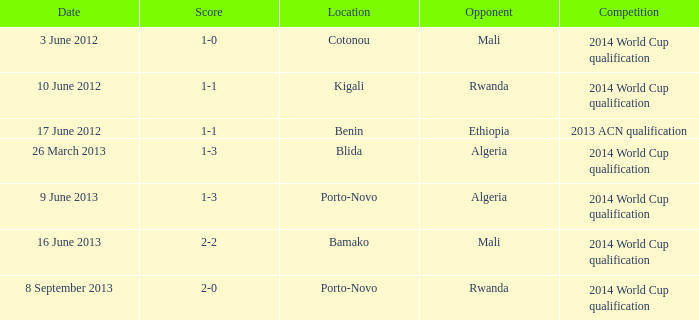What competition is located in bamako? 2014 World Cup qualification. 